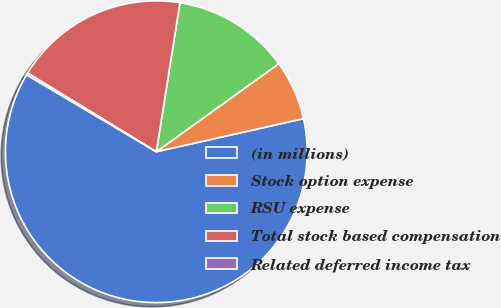Convert chart. <chart><loc_0><loc_0><loc_500><loc_500><pie_chart><fcel>(in millions)<fcel>Stock option expense<fcel>RSU expense<fcel>Total stock based compensation<fcel>Related deferred income tax<nl><fcel>62.04%<fcel>6.4%<fcel>12.58%<fcel>18.76%<fcel>0.22%<nl></chart> 